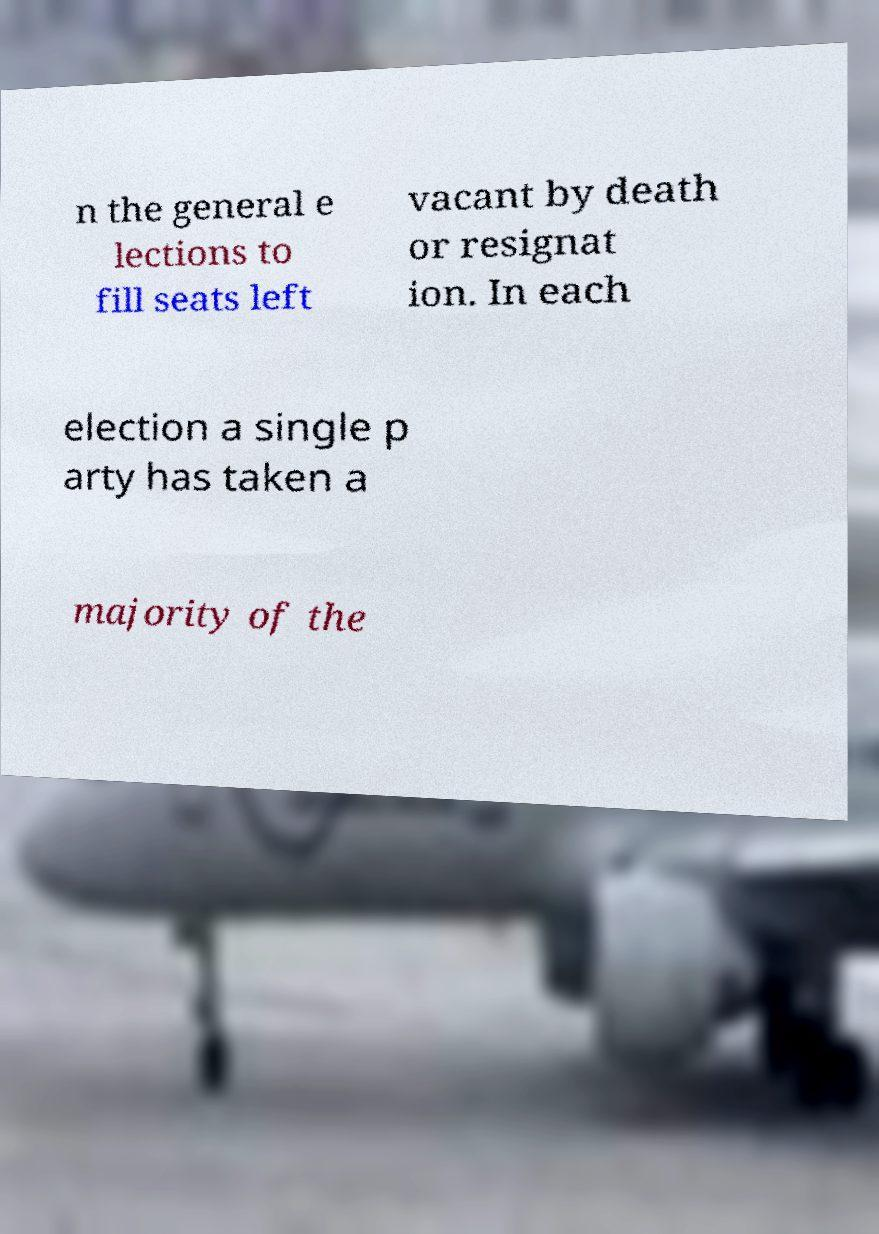Could you assist in decoding the text presented in this image and type it out clearly? n the general e lections to fill seats left vacant by death or resignat ion. In each election a single p arty has taken a majority of the 